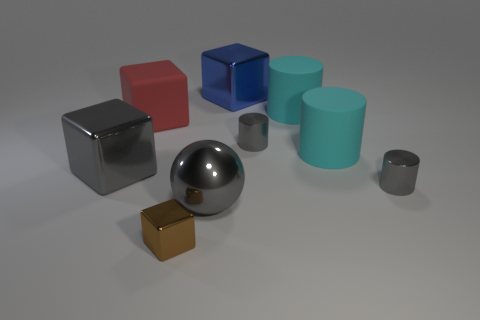Subtract all purple cubes. How many gray cylinders are left? 2 Subtract all metal cubes. How many cubes are left? 1 Subtract 1 cylinders. How many cylinders are left? 3 Subtract all gray cubes. How many cubes are left? 3 Add 1 big gray metal cubes. How many objects exist? 10 Subtract all cylinders. How many objects are left? 5 Subtract 1 gray spheres. How many objects are left? 8 Subtract all green cylinders. Subtract all purple cubes. How many cylinders are left? 4 Subtract all brown cubes. Subtract all rubber things. How many objects are left? 5 Add 6 large matte objects. How many large matte objects are left? 9 